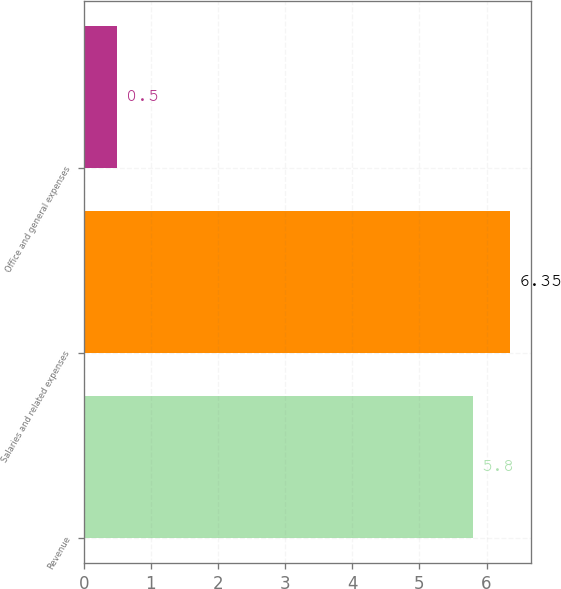<chart> <loc_0><loc_0><loc_500><loc_500><bar_chart><fcel>Revenue<fcel>Salaries and related expenses<fcel>Office and general expenses<nl><fcel>5.8<fcel>6.35<fcel>0.5<nl></chart> 